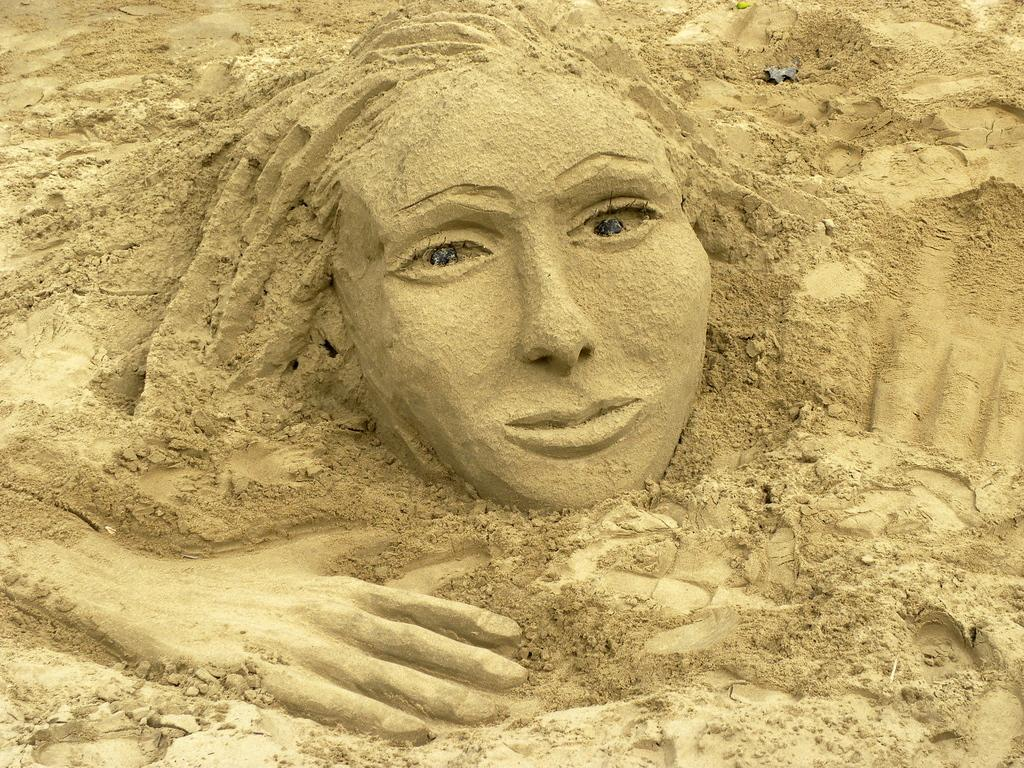What type of art is featured in the image? The image contains sand art. What type of pancake is being served at the industry depicted in the image? There is no industry or pancake present in the image; it features sand art. 